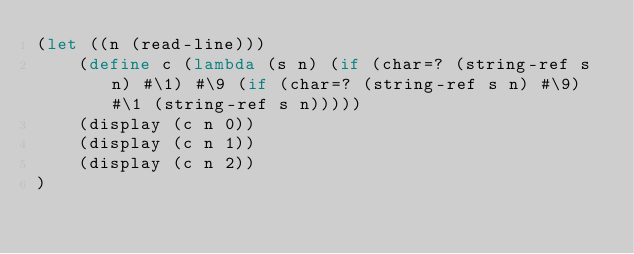<code> <loc_0><loc_0><loc_500><loc_500><_Scheme_>(let ((n (read-line))) 
    (define c (lambda (s n) (if (char=? (string-ref s n) #\1) #\9 (if (char=? (string-ref s n) #\9) #\1 (string-ref s n)))))
    (display (c n 0))
    (display (c n 1))
    (display (c n 2))
)</code> 